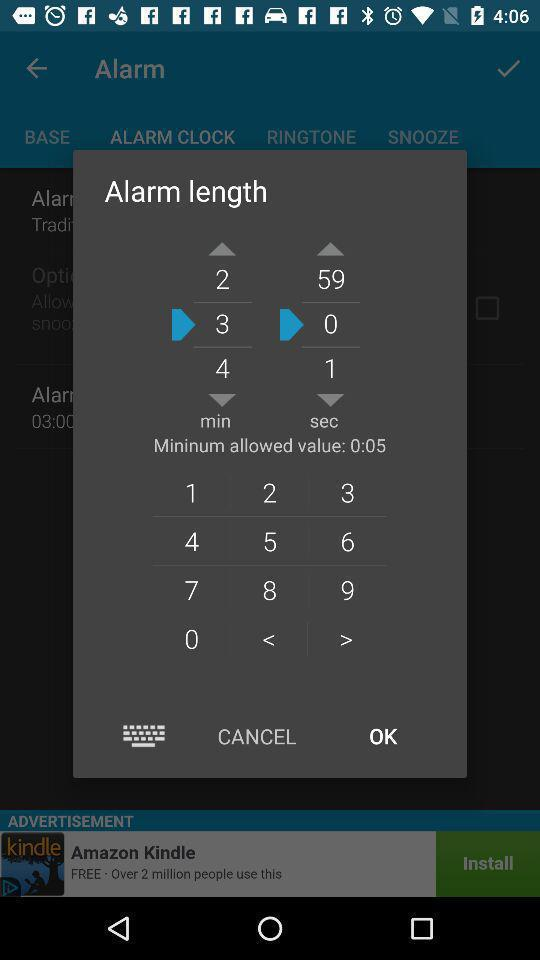What is the minimum allowed value for an alarm? The minimum allowed value is 5 seconds. 